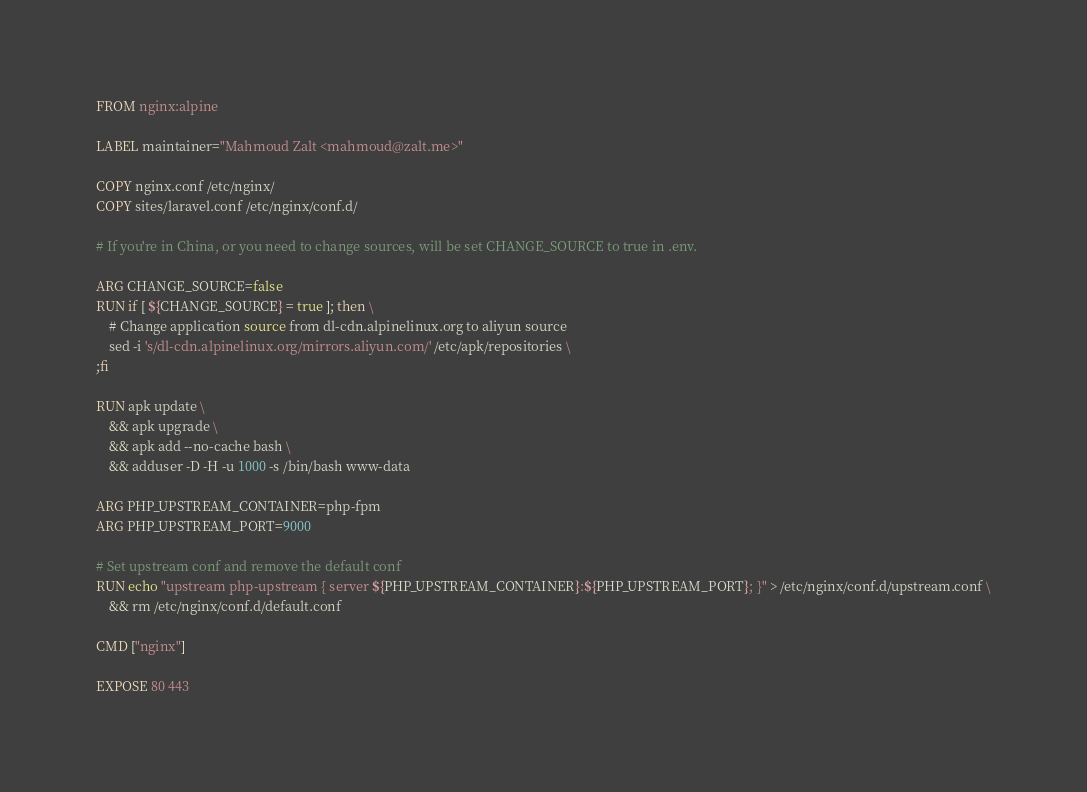<code> <loc_0><loc_0><loc_500><loc_500><_Dockerfile_>FROM nginx:alpine

LABEL maintainer="Mahmoud Zalt <mahmoud@zalt.me>"

COPY nginx.conf /etc/nginx/
COPY sites/laravel.conf /etc/nginx/conf.d/

# If you're in China, or you need to change sources, will be set CHANGE_SOURCE to true in .env.

ARG CHANGE_SOURCE=false
RUN if [ ${CHANGE_SOURCE} = true ]; then \
    # Change application source from dl-cdn.alpinelinux.org to aliyun source
    sed -i 's/dl-cdn.alpinelinux.org/mirrors.aliyun.com/' /etc/apk/repositories \
;fi

RUN apk update \
    && apk upgrade \
    && apk add --no-cache bash \
    && adduser -D -H -u 1000 -s /bin/bash www-data

ARG PHP_UPSTREAM_CONTAINER=php-fpm
ARG PHP_UPSTREAM_PORT=9000

# Set upstream conf and remove the default conf
RUN echo "upstream php-upstream { server ${PHP_UPSTREAM_CONTAINER}:${PHP_UPSTREAM_PORT}; }" > /etc/nginx/conf.d/upstream.conf \
    && rm /etc/nginx/conf.d/default.conf

CMD ["nginx"]

EXPOSE 80 443
</code> 